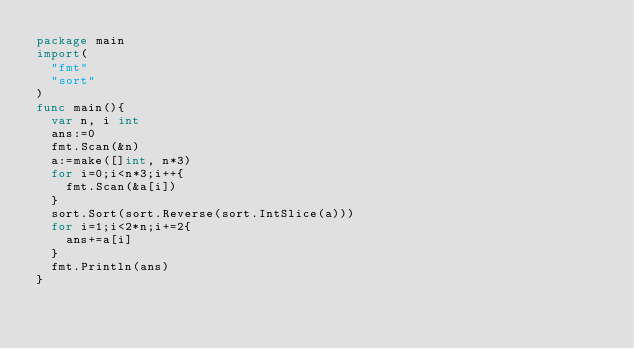<code> <loc_0><loc_0><loc_500><loc_500><_Go_>package main
import(
  "fmt"
  "sort"
)
func main(){
  var n, i int
  ans:=0
  fmt.Scan(&n)
  a:=make([]int, n*3)
  for i=0;i<n*3;i++{
    fmt.Scan(&a[i])
  }
  sort.Sort(sort.Reverse(sort.IntSlice(a)))
  for i=1;i<2*n;i+=2{
    ans+=a[i]
  }
  fmt.Println(ans)
}
</code> 